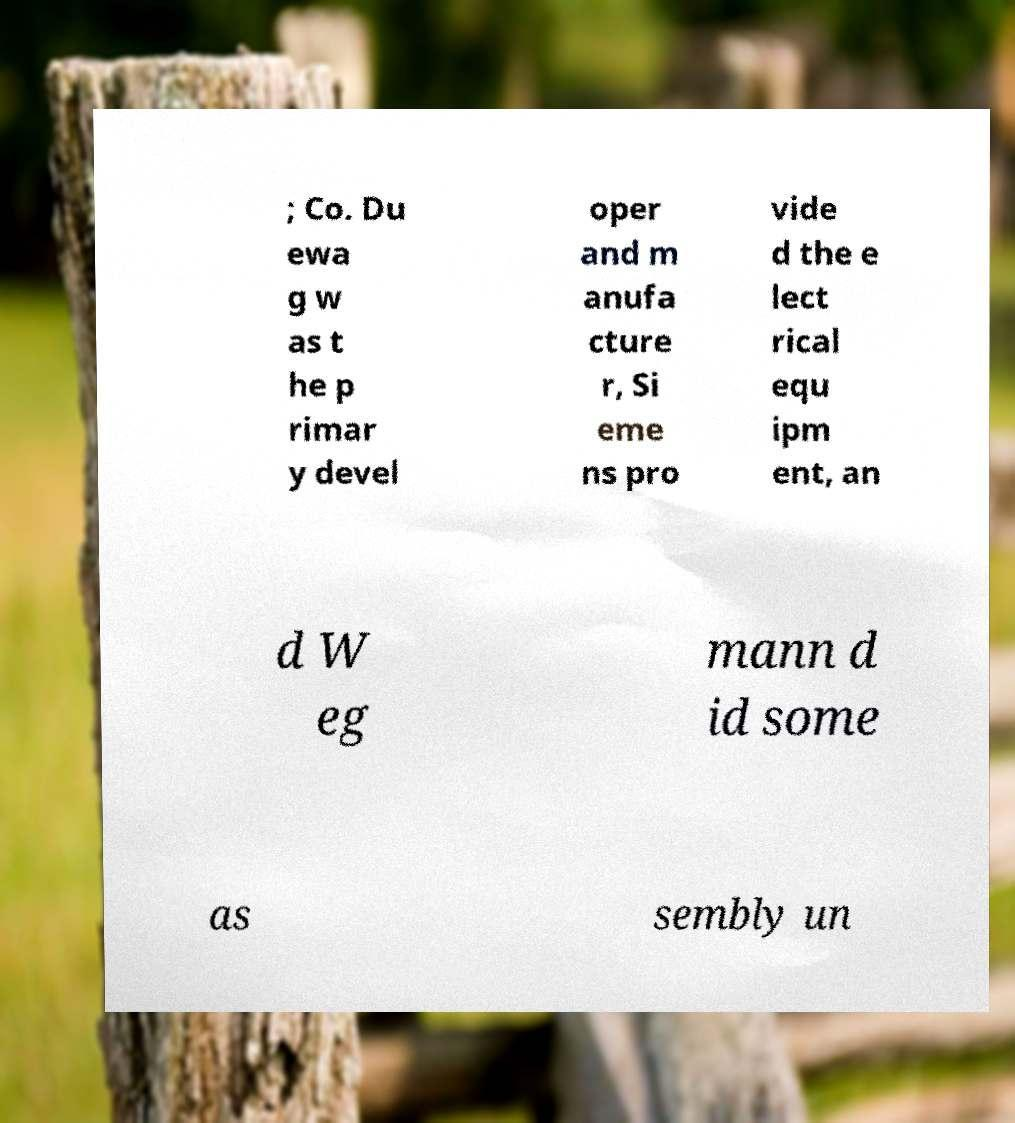Could you extract and type out the text from this image? ; Co. Du ewa g w as t he p rimar y devel oper and m anufa cture r, Si eme ns pro vide d the e lect rical equ ipm ent, an d W eg mann d id some as sembly un 